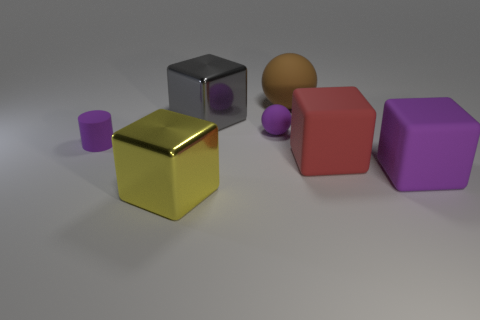How does the light interact with the different materials present? The lighting in the image creates distinct effects depending on the material properties of each object. The gold cube brightly reflects the light, showcasing its glossy texture, while the rubbery objects have more subdued reflections due to their less reflective surfaces. The matte ball diffuses light uniformly, resulting in no visible reflections or highlights. These differences highlight the varying material characteristics such as shininess and texture. Which direction does the light seem to be coming from? The light appears to be coming from the upper part of the image, possibly from a source located above and slightly in front of the objects. This inference is based on the shadows cast behind and to the right of the objects, and the placement of the highlights on the gold cube and the leftmost objects' surfaces. 